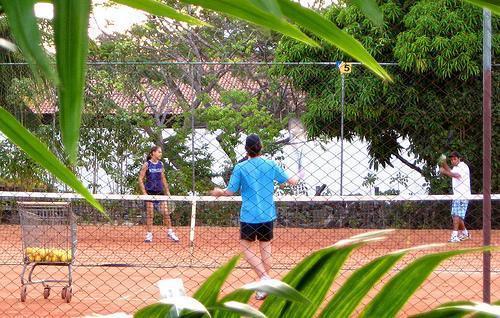How many are wearing shorts?
Give a very brief answer. 3. How many players are there?
Give a very brief answer. 3. How many people are on the tennis court?
Give a very brief answer. 3. How many people are pictured?
Give a very brief answer. 3. 